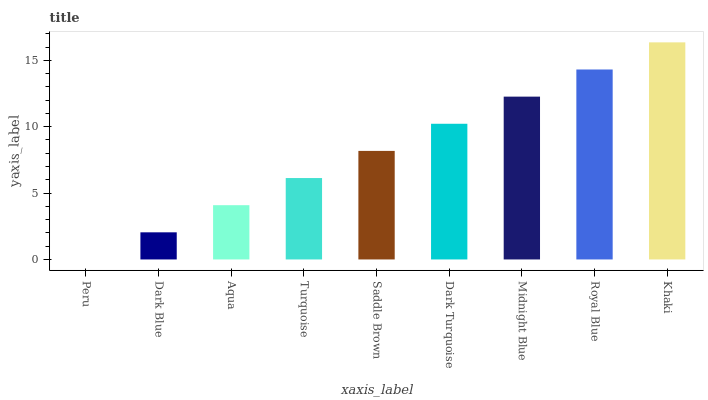Is Peru the minimum?
Answer yes or no. Yes. Is Khaki the maximum?
Answer yes or no. Yes. Is Dark Blue the minimum?
Answer yes or no. No. Is Dark Blue the maximum?
Answer yes or no. No. Is Dark Blue greater than Peru?
Answer yes or no. Yes. Is Peru less than Dark Blue?
Answer yes or no. Yes. Is Peru greater than Dark Blue?
Answer yes or no. No. Is Dark Blue less than Peru?
Answer yes or no. No. Is Saddle Brown the high median?
Answer yes or no. Yes. Is Saddle Brown the low median?
Answer yes or no. Yes. Is Aqua the high median?
Answer yes or no. No. Is Dark Blue the low median?
Answer yes or no. No. 